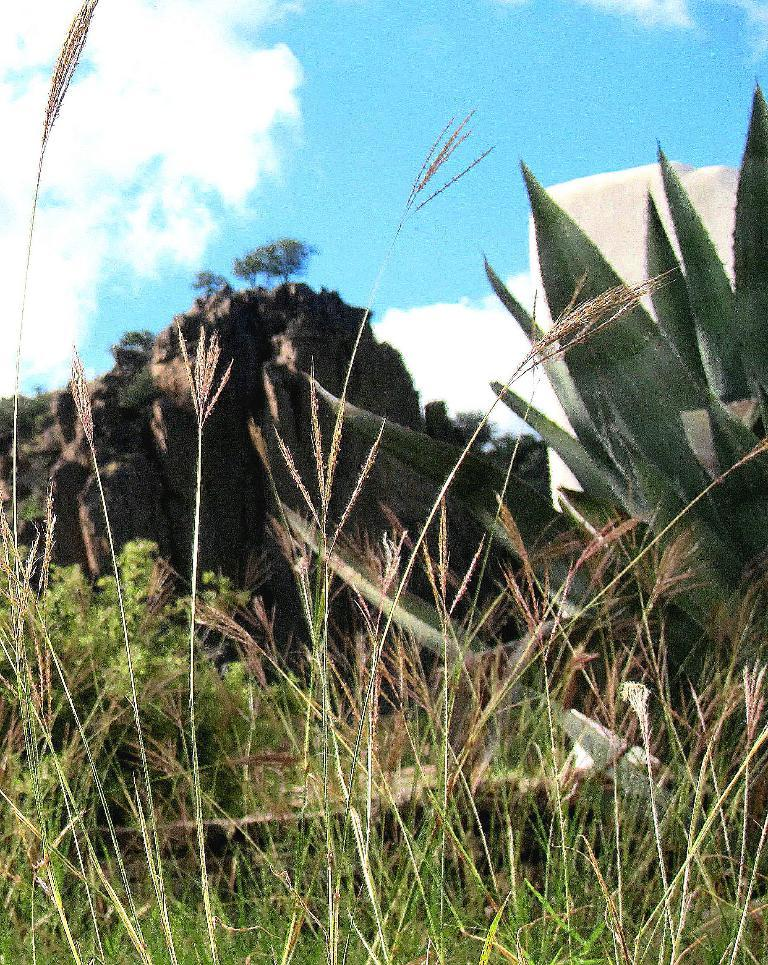What type of vegetation can be seen in the image? There is grass and plants visible in the image. What other elements can be seen in the background of the image? There are rocks, trees, and the sky visible in the background of the image. What type of ice can be seen on the edge of the grass in the image? There is no ice present in the image, and the edge of the grass is not mentioned in the provided facts. 